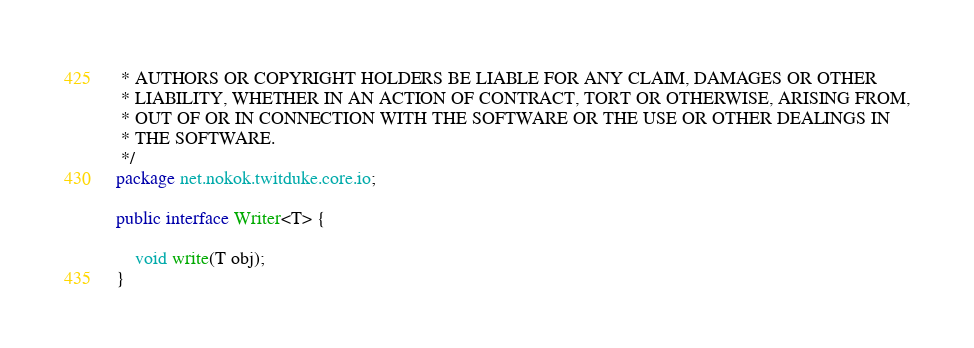<code> <loc_0><loc_0><loc_500><loc_500><_Java_> * AUTHORS OR COPYRIGHT HOLDERS BE LIABLE FOR ANY CLAIM, DAMAGES OR OTHER
 * LIABILITY, WHETHER IN AN ACTION OF CONTRACT, TORT OR OTHERWISE, ARISING FROM,
 * OUT OF OR IN CONNECTION WITH THE SOFTWARE OR THE USE OR OTHER DEALINGS IN
 * THE SOFTWARE.
 */
package net.nokok.twitduke.core.io;

public interface Writer<T> {

    void write(T obj);
}
</code> 